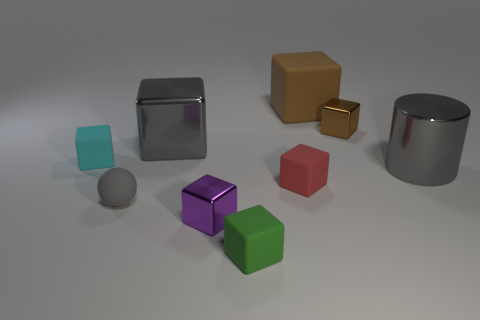Are there an equal number of small matte things in front of the small purple object and large gray metal things?
Your answer should be very brief. No. Is the shape of the small brown metallic thing the same as the small cyan object?
Your answer should be very brief. Yes. Is there any other thing that has the same color as the matte sphere?
Provide a succinct answer. Yes. There is a gray object that is both in front of the tiny cyan thing and to the left of the small brown metallic block; what shape is it?
Your response must be concise. Sphere. Is the number of large things that are on the left side of the tiny cyan object the same as the number of red cubes that are behind the big cylinder?
Offer a very short reply. Yes. What number of balls are brown metal things or small cyan rubber things?
Your answer should be compact. 0. What number of blue blocks are made of the same material as the red thing?
Keep it short and to the point. 0. The tiny rubber thing that is the same color as the big cylinder is what shape?
Your answer should be compact. Sphere. The small block that is behind the gray metal cylinder and to the left of the tiny green cube is made of what material?
Offer a very short reply. Rubber. What is the shape of the purple metallic thing that is in front of the tiny cyan cube?
Provide a succinct answer. Cube. 